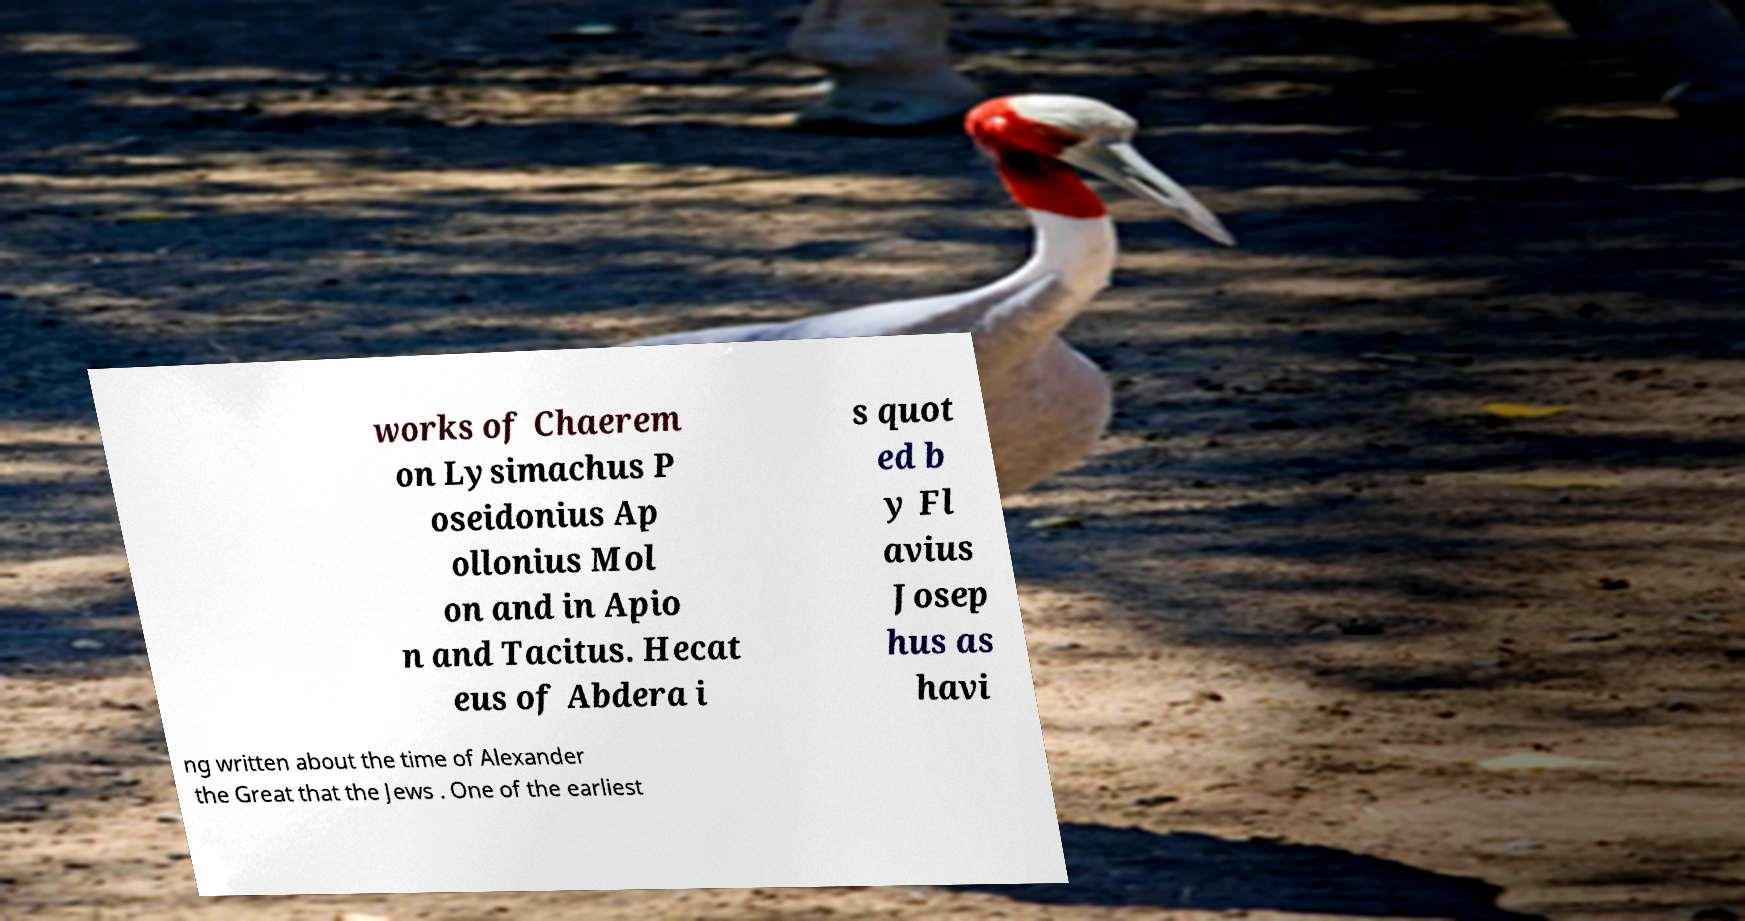For documentation purposes, I need the text within this image transcribed. Could you provide that? works of Chaerem on Lysimachus P oseidonius Ap ollonius Mol on and in Apio n and Tacitus. Hecat eus of Abdera i s quot ed b y Fl avius Josep hus as havi ng written about the time of Alexander the Great that the Jews . One of the earliest 